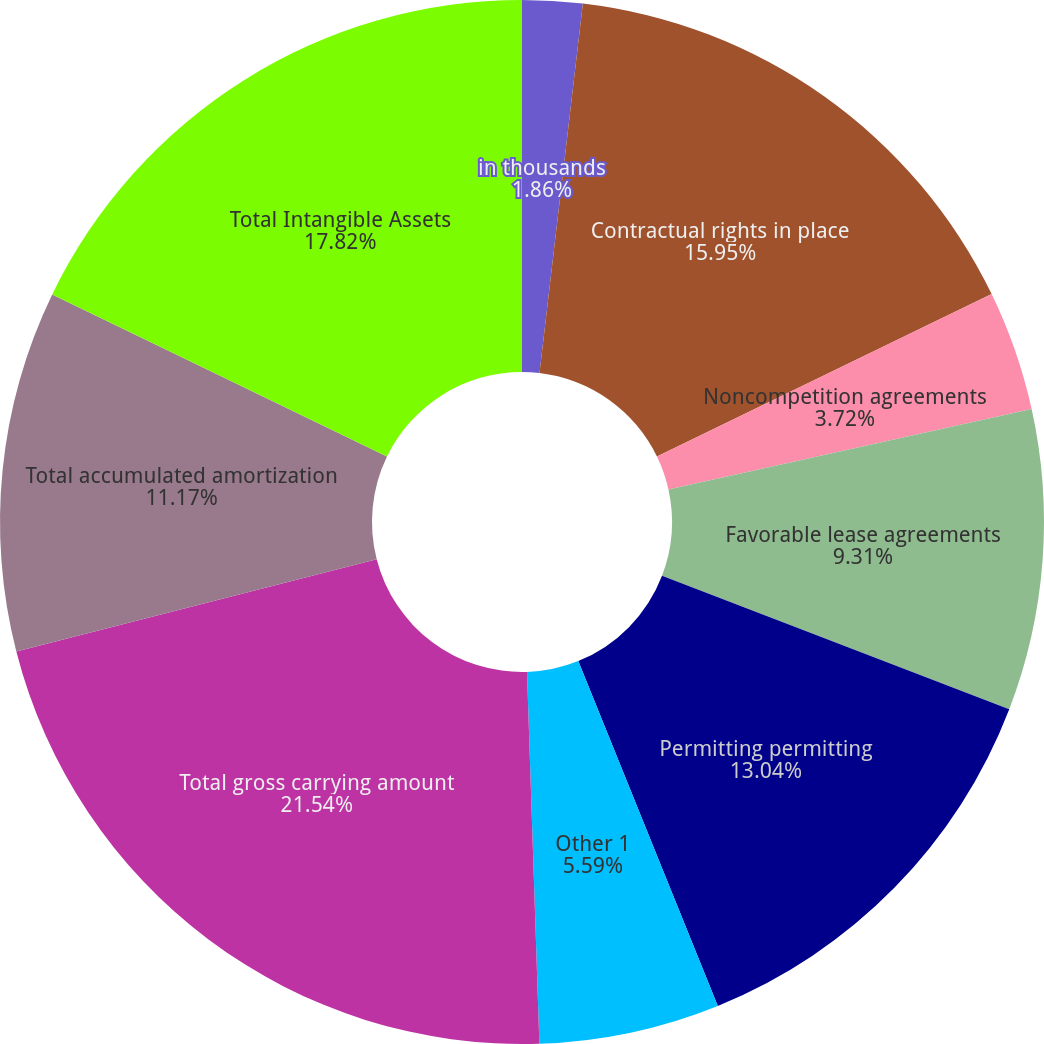Convert chart to OTSL. <chart><loc_0><loc_0><loc_500><loc_500><pie_chart><fcel>in thousands<fcel>Contractual rights in place<fcel>Noncompetition agreements<fcel>Favorable lease agreements<fcel>Permitting permitting<fcel>Other 1<fcel>Total gross carrying amount<fcel>Total accumulated amortization<fcel>Total Intangible Assets<fcel>Intangible Assets with<nl><fcel>1.86%<fcel>15.95%<fcel>3.72%<fcel>9.31%<fcel>13.04%<fcel>5.59%<fcel>21.54%<fcel>11.17%<fcel>17.82%<fcel>0.0%<nl></chart> 